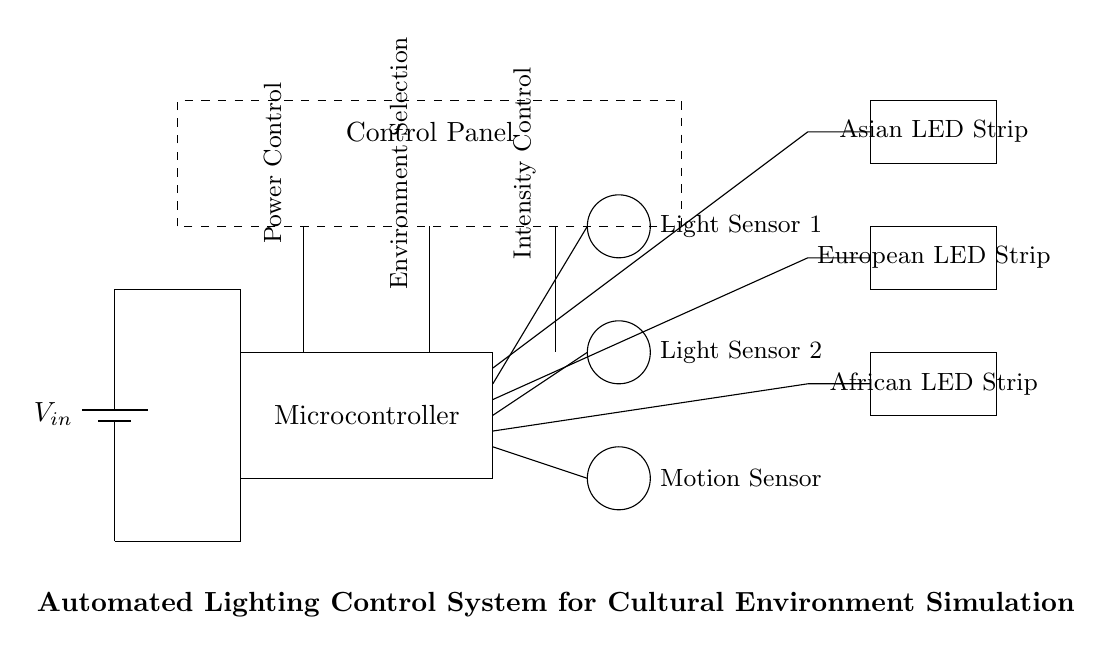What is the main control component of this circuit? The main control component is the microcontroller, as it coordinates the input from the sensors and controls the output to the LED strips.
Answer: microcontroller How many LED strips are present in the circuit? There are three LED strips labeled for different cultural environments: Asian, European, and African.
Answer: three What type of sensors does this circuit use? The circuit uses light sensors and a motion sensor, which collect data about the environment to adjust the lighting accordingly.
Answer: light and motion sensors Which component is responsible for power supply? The component providing power supply is the battery, which supplies the necessary voltage to the entire system.
Answer: battery What is the purpose of the control panel? The control panel allows users to interact with the system to select environments, control intensity, and manage power, enhancing user experience and functionality.
Answer: user interaction How are the light sensors connected to the microcontroller? The light sensors are connected to the microcontroller via wires that run from the sensors to the microcontroller, enabling data transmission for lighting adjustments.
Answer: wired connections What do the dashed lines represent in this circuit? The dashed lines represent the outline of the control panel, indicating a user-interface section distinct from the main circuit components.
Answer: control panel outline 